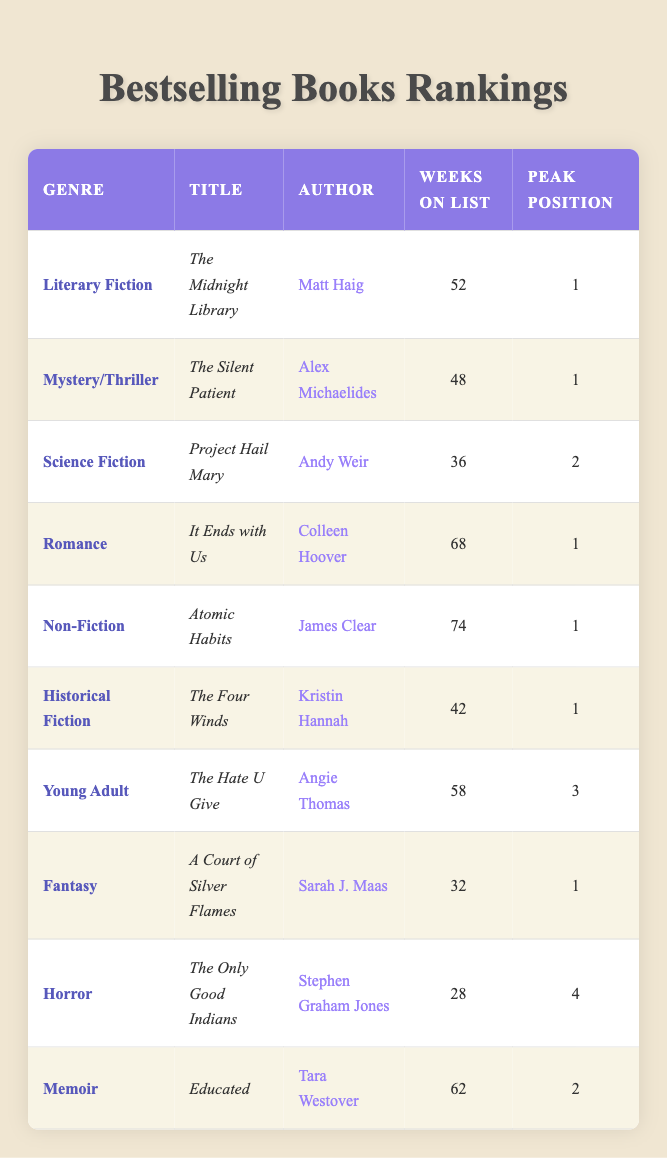What is the title of the bestselling book in the Romance genre? The table lists multiple genres along with their titles. In the Romance category, the title "It Ends with Us" is indicated as the bestselling book.
Answer: It Ends with Us How many weeks did "Atomic Habits" spend on the list? The table explicitly states that "Atomic Habits" is listed for a total of 74 weeks.
Answer: 74 weeks Which genre had the highest peak position? Looking at the Peak Position data, "Literary Fiction" and "Mystery/Thriller" both peaked at position 1, which is the highest.
Answer: Literary Fiction and Mystery/Thriller What is the average number of weeks on the list for all books in the table? First, sum all weeks: 52 + 48 + 36 + 68 + 74 + 42 + 58 + 32 + 28 + 62 = 440. There are 10 books, so the average is 440 / 10 = 44.
Answer: 44 Is "The Only Good Indians" in the Horror genre? The table lists "The Only Good Indians" under the Horror genre, confirming that it indeed belongs in that category.
Answer: Yes Which author had the most weeks on the list? By checking the "Weeks on List" column, "Atomic Habits" by James Clear has the most weeks at 74.
Answer: James Clear What percentage of the titles peaked at position 1? There are 10 titles total, and 5 of them peaked at position 1. Calculating the percentage gives (5/10) * 100 = 50%.
Answer: 50% Which genre had the least amount of weeks on the list? The Horror genre, "The Only Good Indians," had the least weeks on the list at 28 weeks.
Answer: Horror 